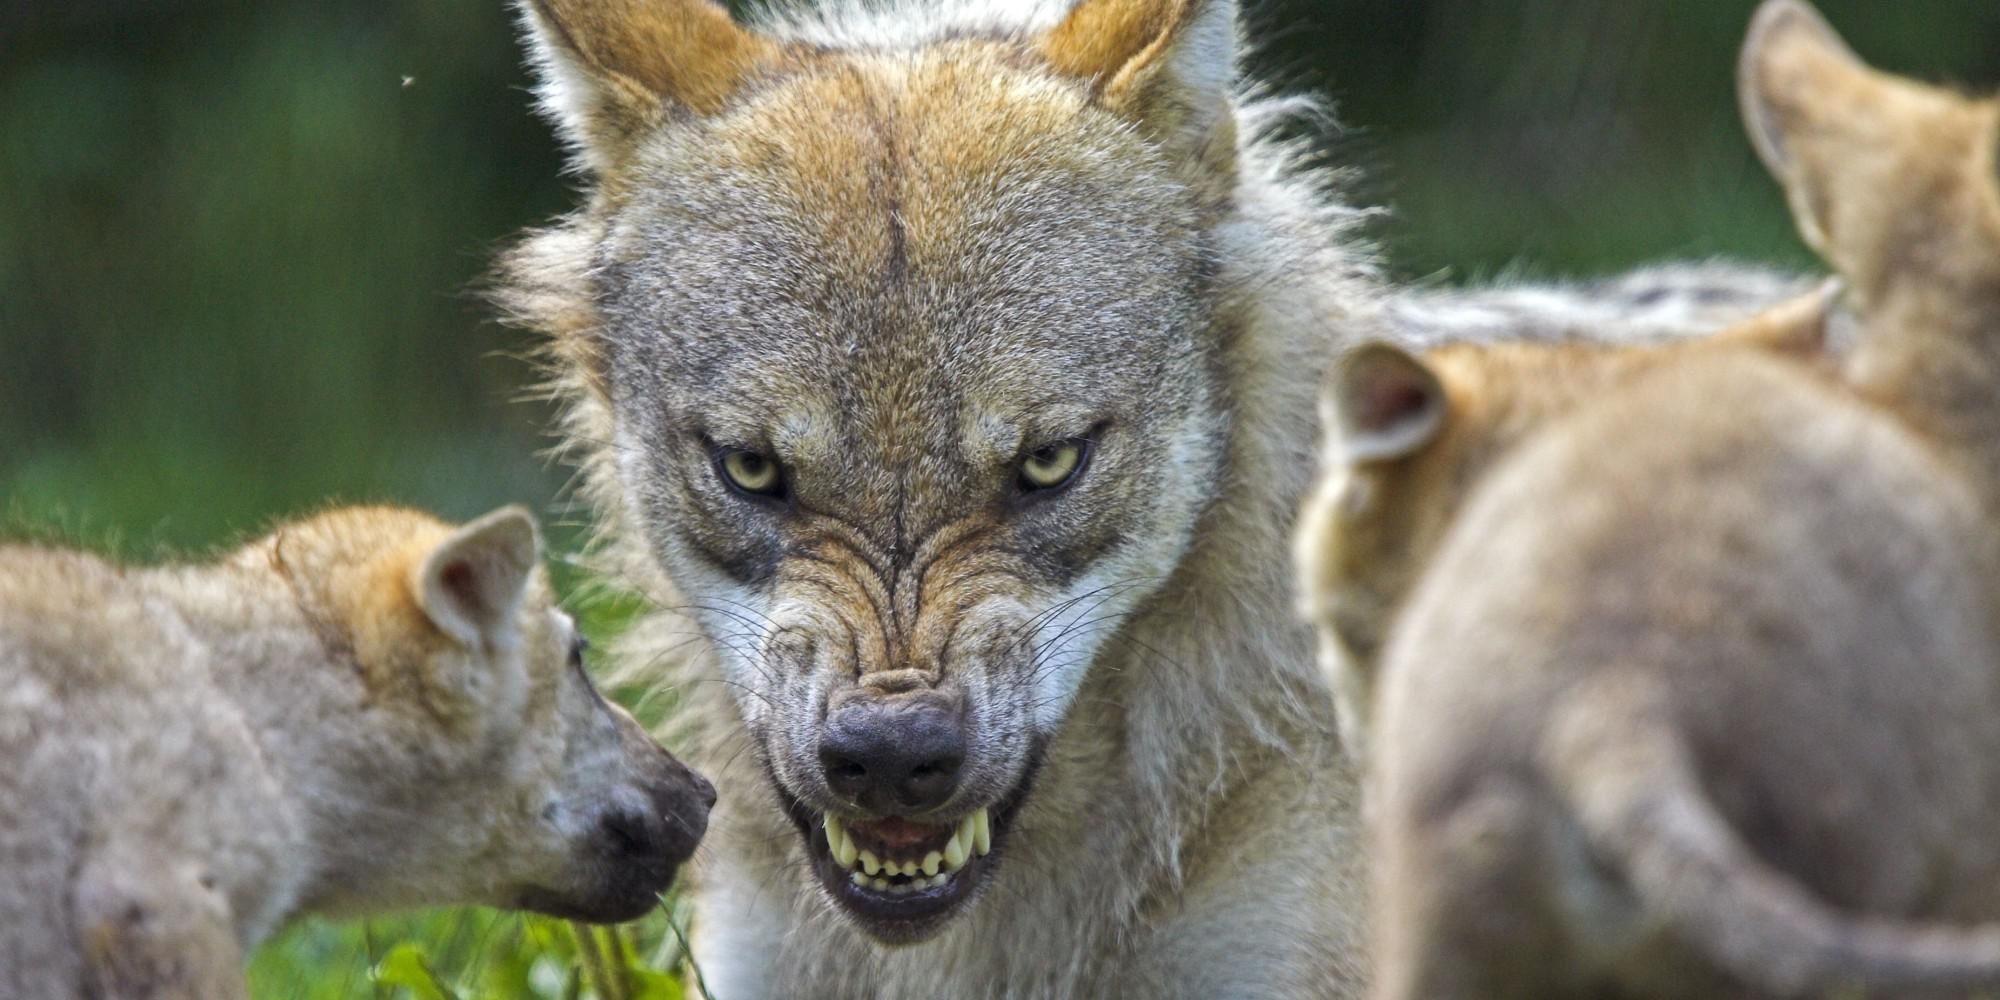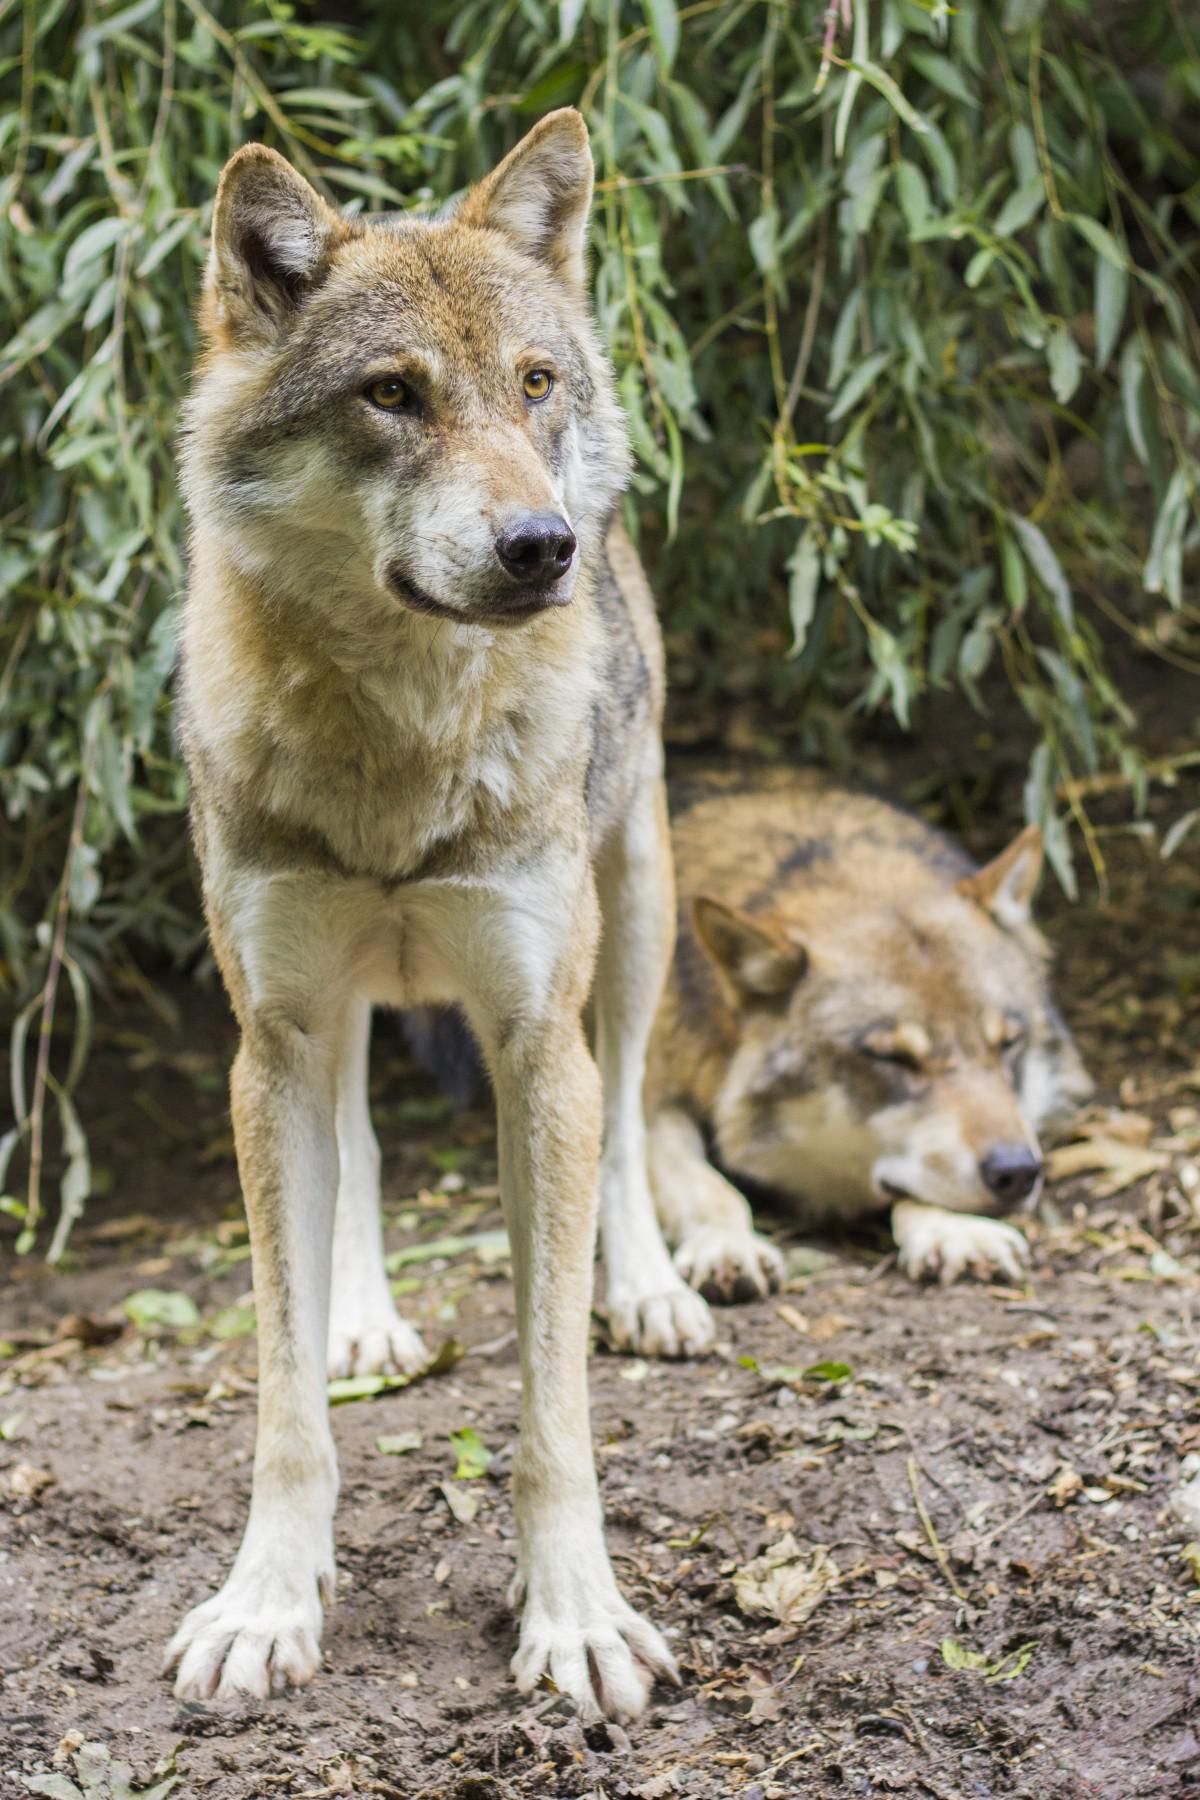The first image is the image on the left, the second image is the image on the right. For the images displayed, is the sentence "The right image contains at least two wolves." factually correct? Answer yes or no. Yes. The first image is the image on the left, the second image is the image on the right. Examine the images to the left and right. Is the description "There are no more than 3 animals in the pair of images." accurate? Answer yes or no. No. 